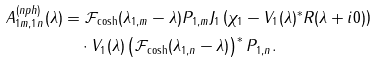<formula> <loc_0><loc_0><loc_500><loc_500>A _ { 1 m , 1 n } ^ { ( n p h ) } ( \lambda ) & = \mathcal { F } _ { \cosh } ( \lambda _ { 1 , m } - \lambda ) P _ { 1 , m } J _ { 1 } \left ( \chi _ { 1 } - V _ { 1 } ( \lambda ) ^ { \ast } R ( \lambda + i 0 ) \right ) \\ & \quad \cdot V _ { 1 } ( \lambda ) \left ( \mathcal { F } _ { \cosh } ( \lambda _ { 1 , n } - \lambda ) \right ) ^ { \ast } P _ { 1 , n } .</formula> 